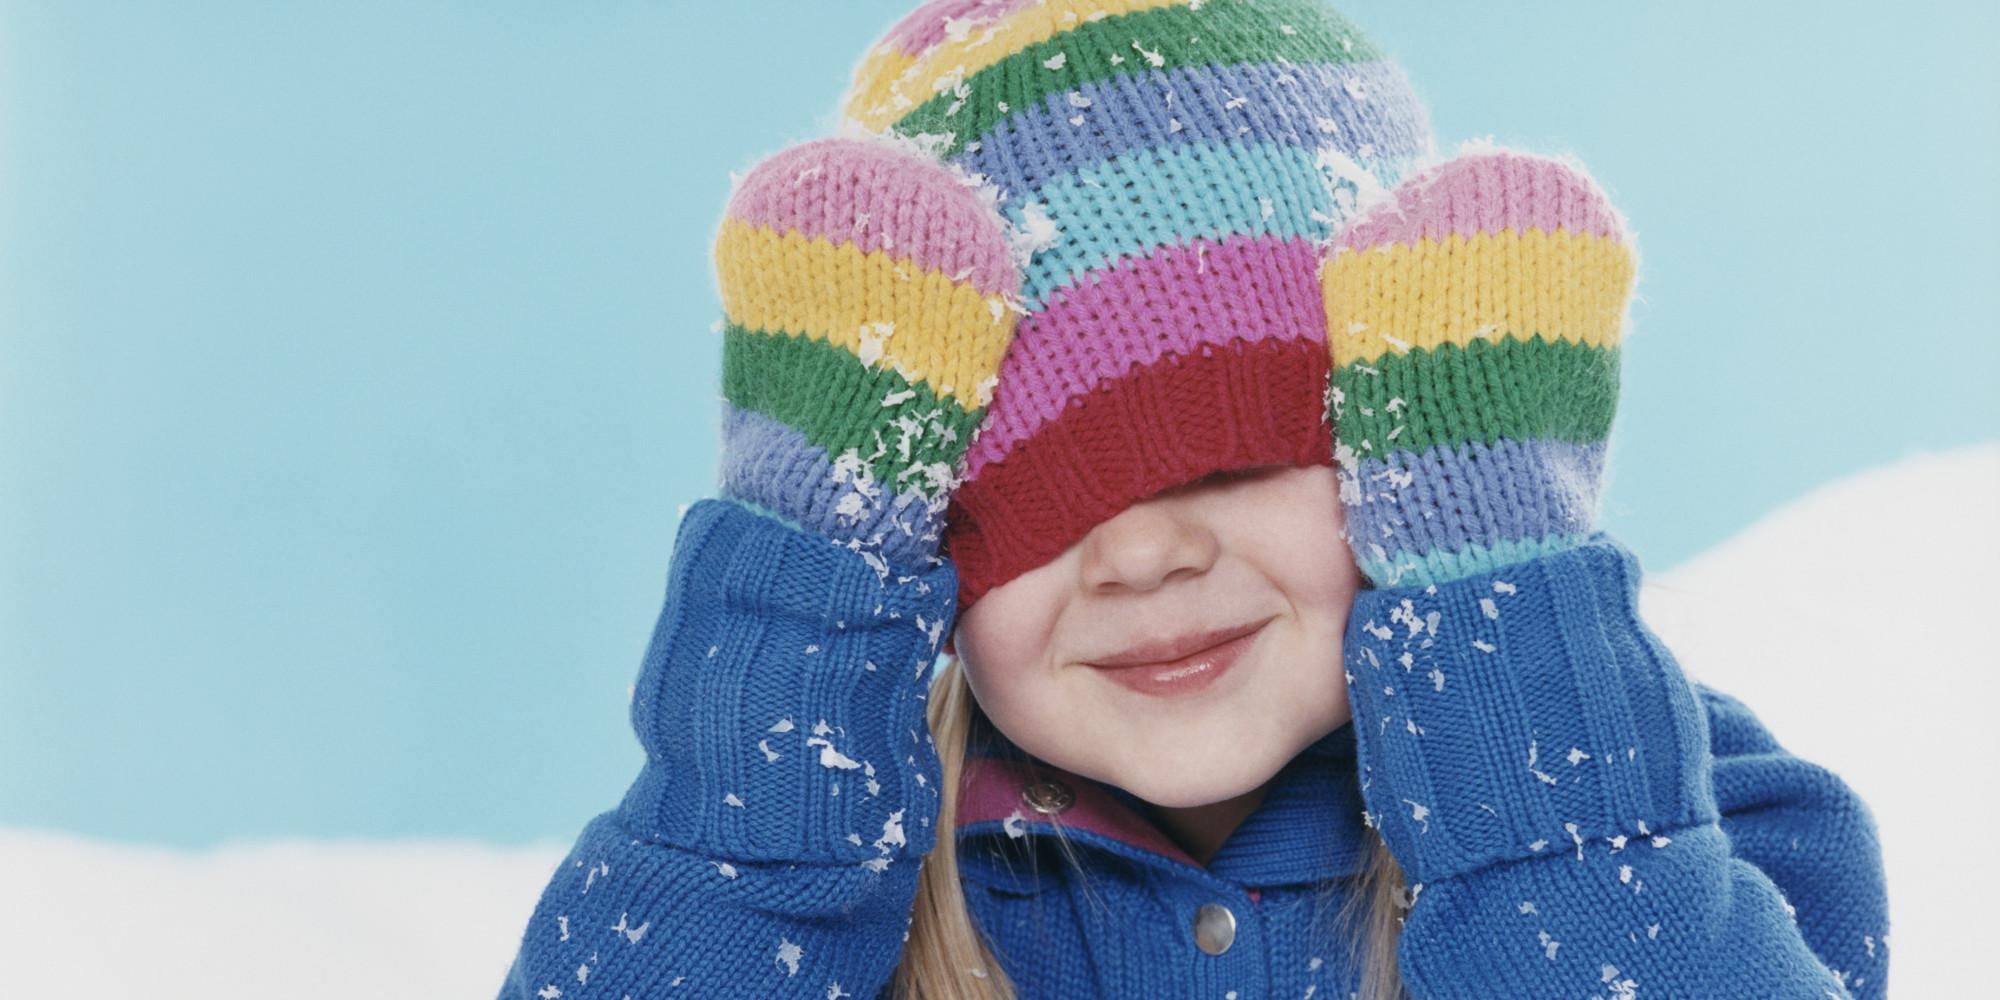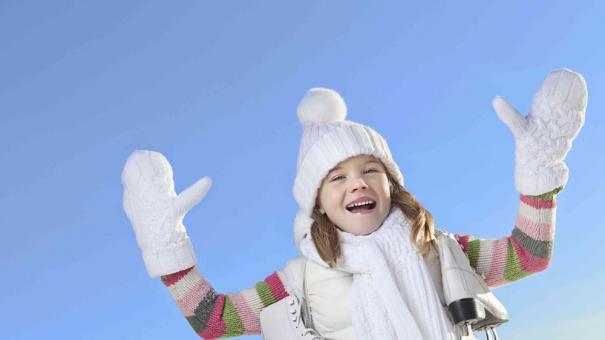The first image is the image on the left, the second image is the image on the right. Given the left and right images, does the statement "There are three mittens in each set of images, and they are all solid colors" hold true? Answer yes or no. No. 